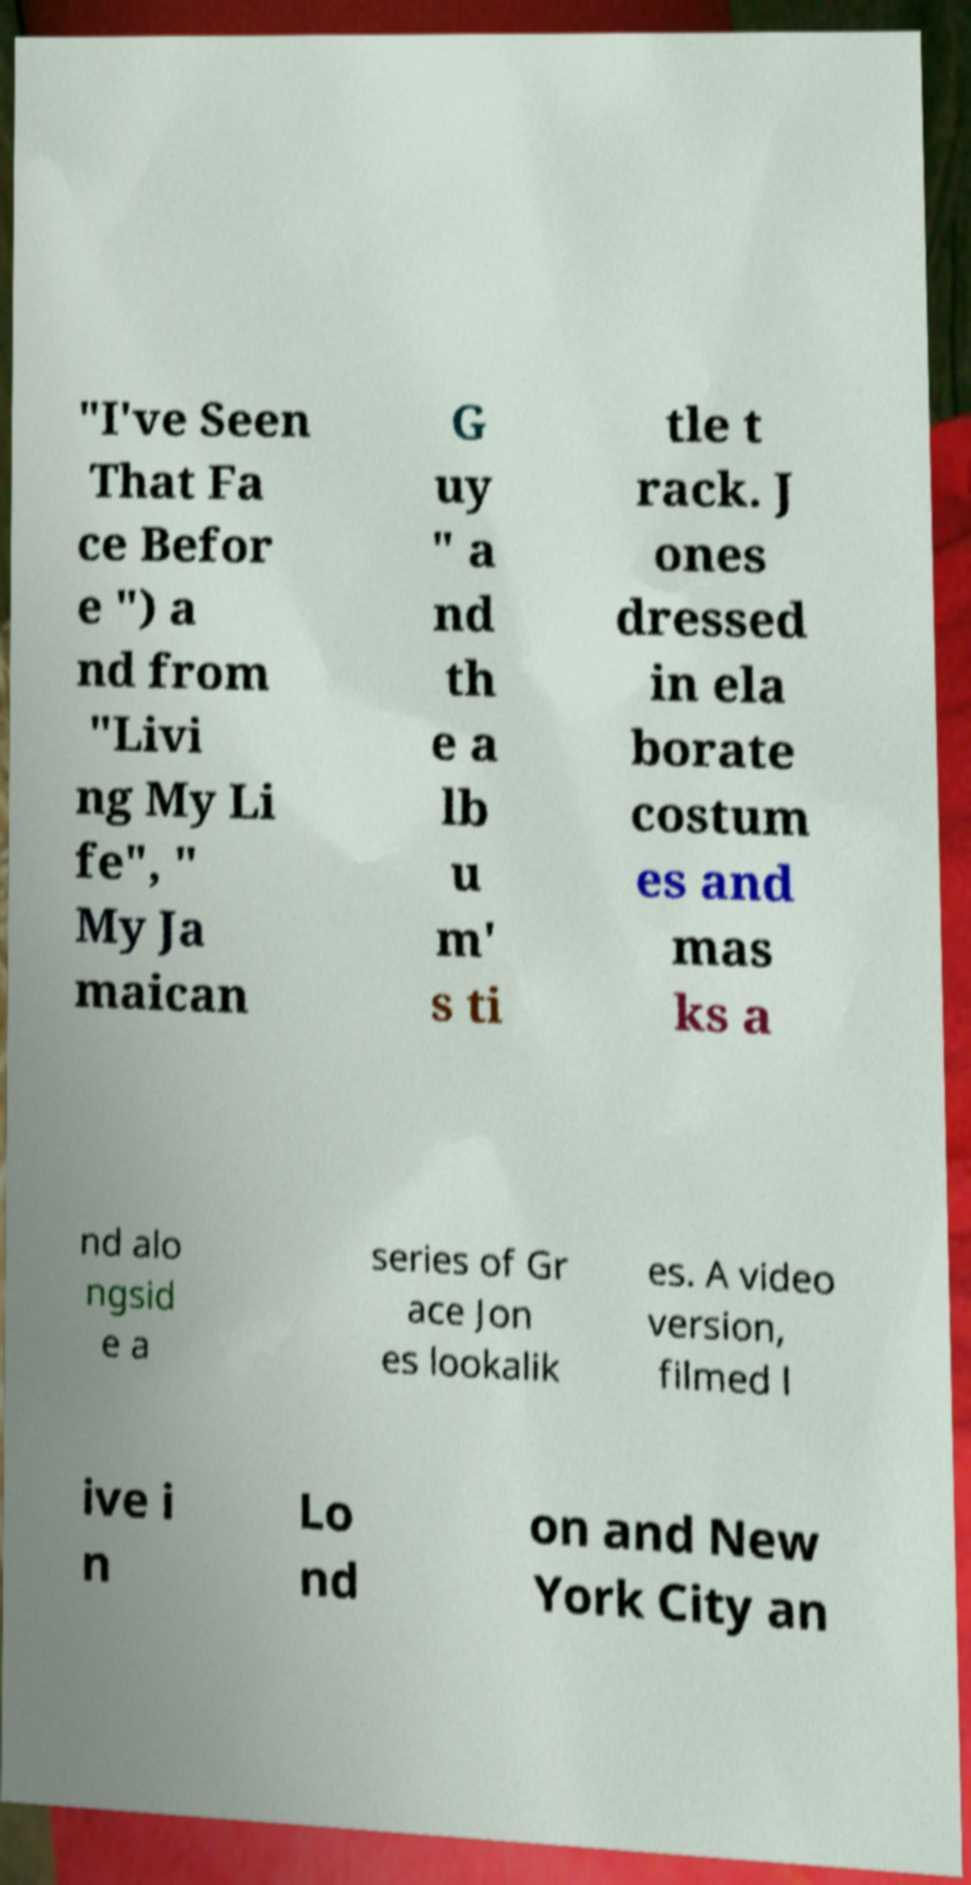I need the written content from this picture converted into text. Can you do that? "I've Seen That Fa ce Befor e ") a nd from "Livi ng My Li fe", " My Ja maican G uy " a nd th e a lb u m' s ti tle t rack. J ones dressed in ela borate costum es and mas ks a nd alo ngsid e a series of Gr ace Jon es lookalik es. A video version, filmed l ive i n Lo nd on and New York City an 